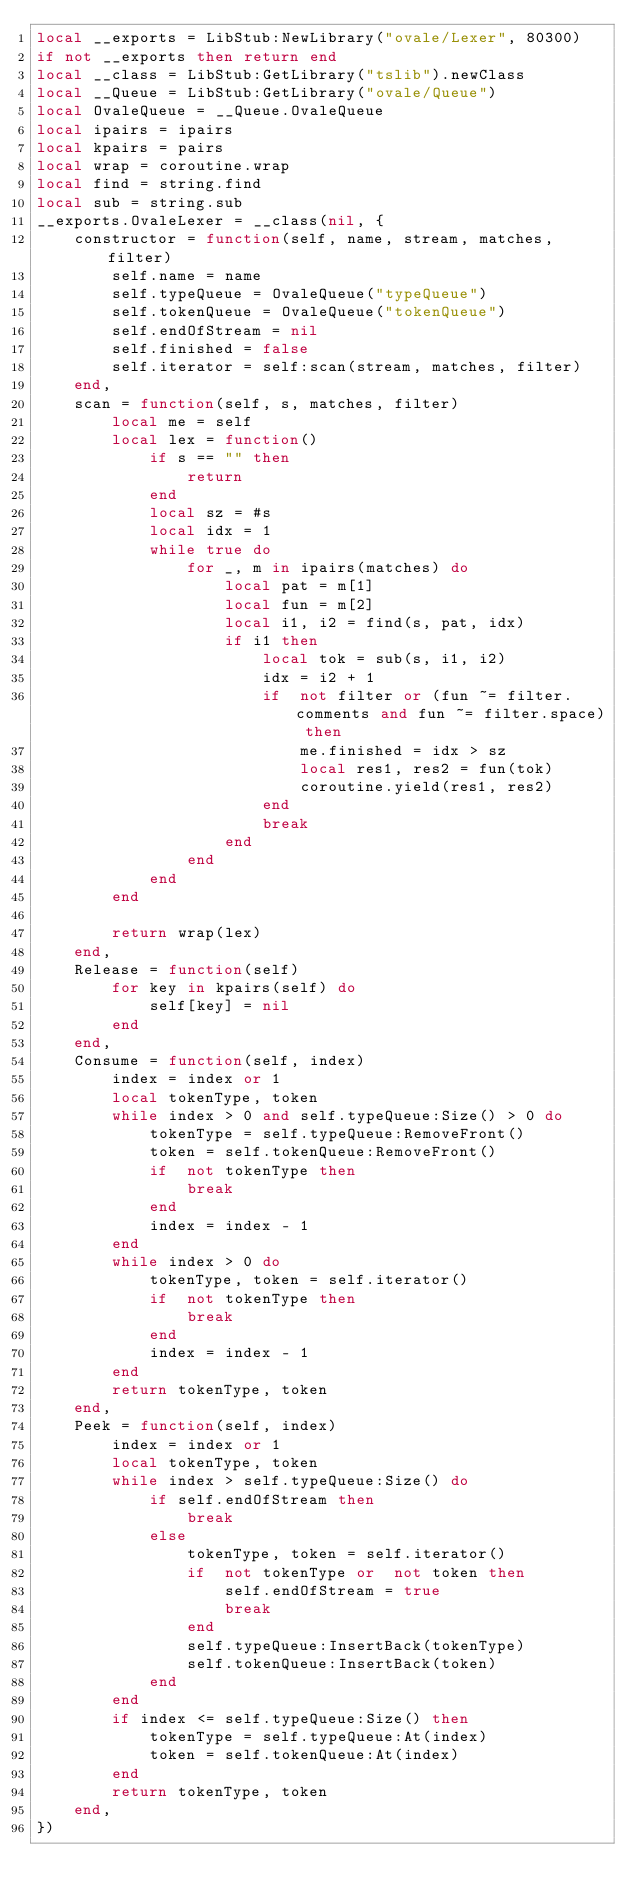Convert code to text. <code><loc_0><loc_0><loc_500><loc_500><_Lua_>local __exports = LibStub:NewLibrary("ovale/Lexer", 80300)
if not __exports then return end
local __class = LibStub:GetLibrary("tslib").newClass
local __Queue = LibStub:GetLibrary("ovale/Queue")
local OvaleQueue = __Queue.OvaleQueue
local ipairs = ipairs
local kpairs = pairs
local wrap = coroutine.wrap
local find = string.find
local sub = string.sub
__exports.OvaleLexer = __class(nil, {
    constructor = function(self, name, stream, matches, filter)
        self.name = name
        self.typeQueue = OvaleQueue("typeQueue")
        self.tokenQueue = OvaleQueue("tokenQueue")
        self.endOfStream = nil
        self.finished = false
        self.iterator = self:scan(stream, matches, filter)
    end,
    scan = function(self, s, matches, filter)
        local me = self
        local lex = function()
            if s == "" then
                return 
            end
            local sz = #s
            local idx = 1
            while true do
                for _, m in ipairs(matches) do
                    local pat = m[1]
                    local fun = m[2]
                    local i1, i2 = find(s, pat, idx)
                    if i1 then
                        local tok = sub(s, i1, i2)
                        idx = i2 + 1
                        if  not filter or (fun ~= filter.comments and fun ~= filter.space) then
                            me.finished = idx > sz
                            local res1, res2 = fun(tok)
                            coroutine.yield(res1, res2)
                        end
                        break
                    end
                end
            end
        end

        return wrap(lex)
    end,
    Release = function(self)
        for key in kpairs(self) do
            self[key] = nil
        end
    end,
    Consume = function(self, index)
        index = index or 1
        local tokenType, token
        while index > 0 and self.typeQueue:Size() > 0 do
            tokenType = self.typeQueue:RemoveFront()
            token = self.tokenQueue:RemoveFront()
            if  not tokenType then
                break
            end
            index = index - 1
        end
        while index > 0 do
            tokenType, token = self.iterator()
            if  not tokenType then
                break
            end
            index = index - 1
        end
        return tokenType, token
    end,
    Peek = function(self, index)
        index = index or 1
        local tokenType, token
        while index > self.typeQueue:Size() do
            if self.endOfStream then
                break
            else
                tokenType, token = self.iterator()
                if  not tokenType or  not token then
                    self.endOfStream = true
                    break
                end
                self.typeQueue:InsertBack(tokenType)
                self.tokenQueue:InsertBack(token)
            end
        end
        if index <= self.typeQueue:Size() then
            tokenType = self.typeQueue:At(index)
            token = self.tokenQueue:At(index)
        end
        return tokenType, token
    end,
})
</code> 